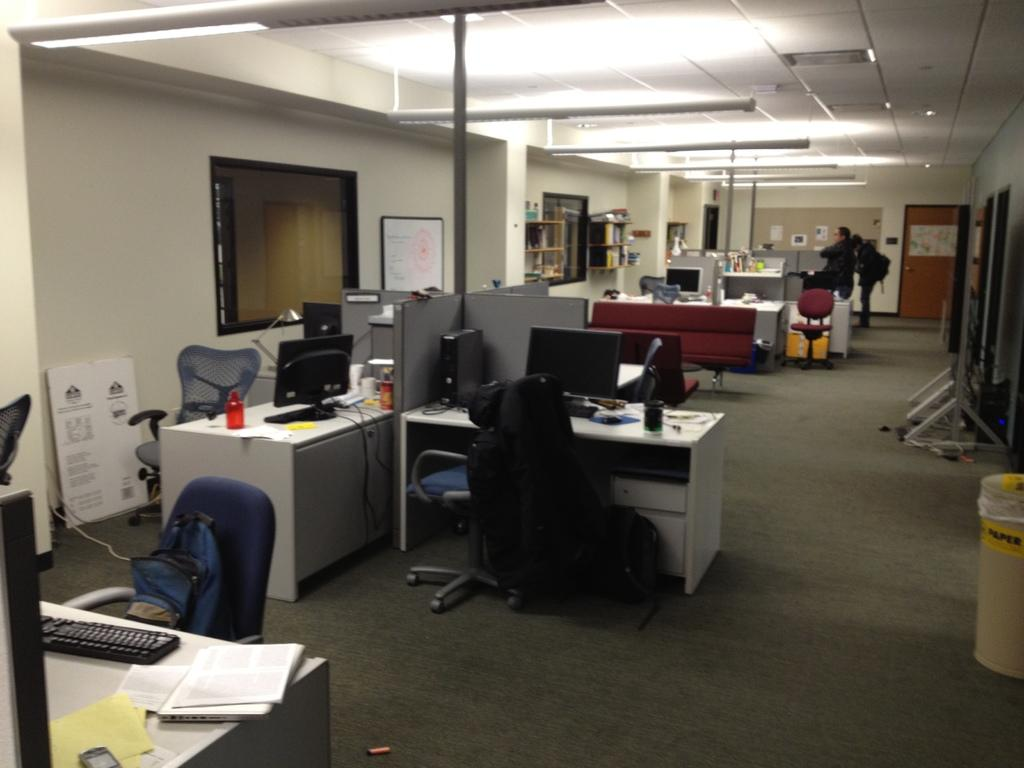How many people are in the room? There are two persons in the room. What furniture is present in the room? There is a table in the room. What electronic devices are on the table? There is a CPU, a monitor, and a keyboard on the table. What other items are on the table? There is paper and a glass on the table. What can be seen in the background of the room? There is a pillar and a name board in the background. What type of leather is covering the horse in the image? There is no horse or leather present in the image. How many stars can be seen in the image? There are no stars visible in the image. 